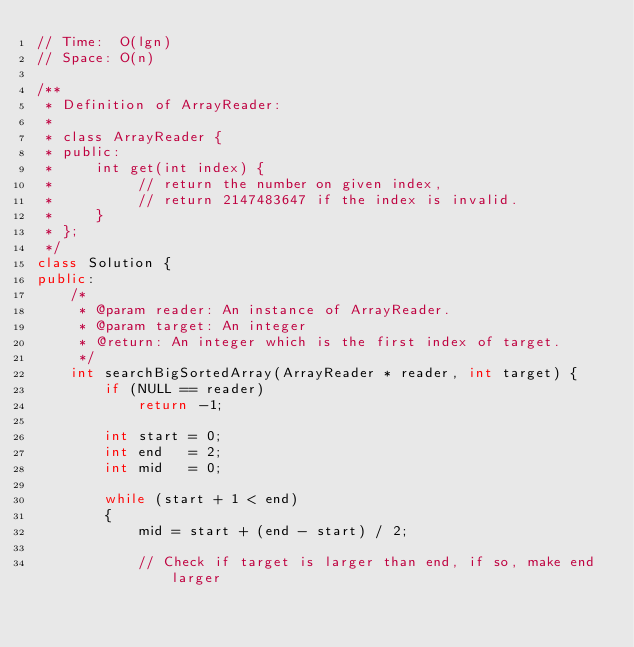<code> <loc_0><loc_0><loc_500><loc_500><_C++_>// Time:  O(lgn)
// Space: O(n)

/**
 * Definition of ArrayReader:
 * 
 * class ArrayReader {
 * public:
 *     int get(int index) {
 *          // return the number on given index, 
 *          // return 2147483647 if the index is invalid.
 *     }
 * };
 */
class Solution {
public:
    /*
     * @param reader: An instance of ArrayReader.
     * @param target: An integer
     * @return: An integer which is the first index of target.
     */
    int searchBigSortedArray(ArrayReader * reader, int target) {
        if (NULL == reader)
            return -1;
            
        int start = 0;
        int end   = 2;
        int mid   = 0;
        
        while (start + 1 < end)
        {
            mid = start + (end - start) / 2;
            
            // Check if target is larger than end, if so, make end larger</code> 